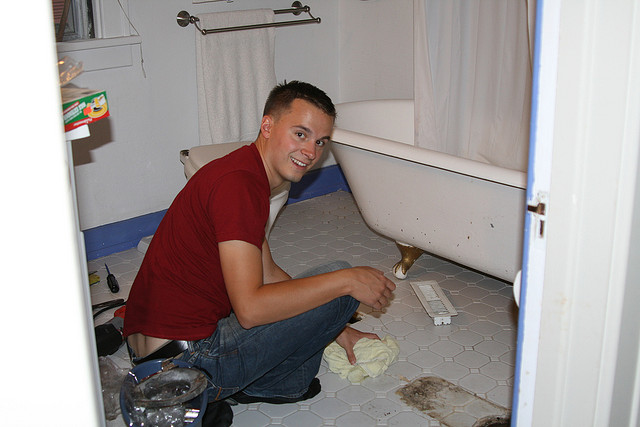What is the man doing in this image? The man appears to be engaged in some sort of cleaning or repair work in the bathroom. He's sitting on the floor and smiling, holding a cleaning cloth in his hand, suggesting he might be cleaning the floor or fixing something near the bathtub. What items can you see on the bathroom floor? On the bathroom floor, you can see a screwdriver near the man's hand, a folded towel, another towel placed to the right of the bathtub, and a box placed below the towel rack. There also seem to be some cleaning supplies and other tools scattered around. 